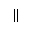<formula> <loc_0><loc_0><loc_500><loc_500>\|</formula> 